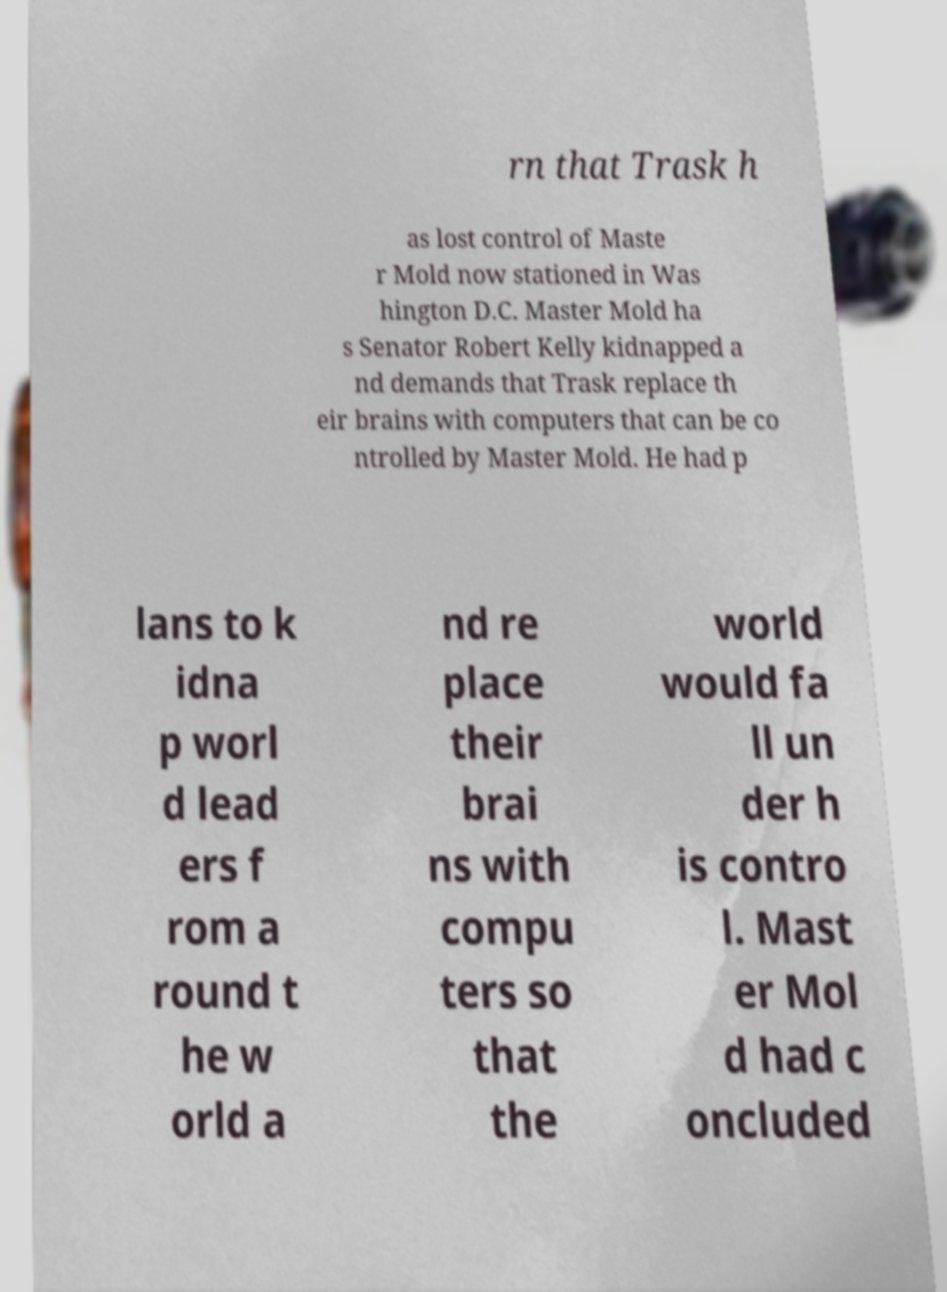Could you assist in decoding the text presented in this image and type it out clearly? rn that Trask h as lost control of Maste r Mold now stationed in Was hington D.C. Master Mold ha s Senator Robert Kelly kidnapped a nd demands that Trask replace th eir brains with computers that can be co ntrolled by Master Mold. He had p lans to k idna p worl d lead ers f rom a round t he w orld a nd re place their brai ns with compu ters so that the world would fa ll un der h is contro l. Mast er Mol d had c oncluded 